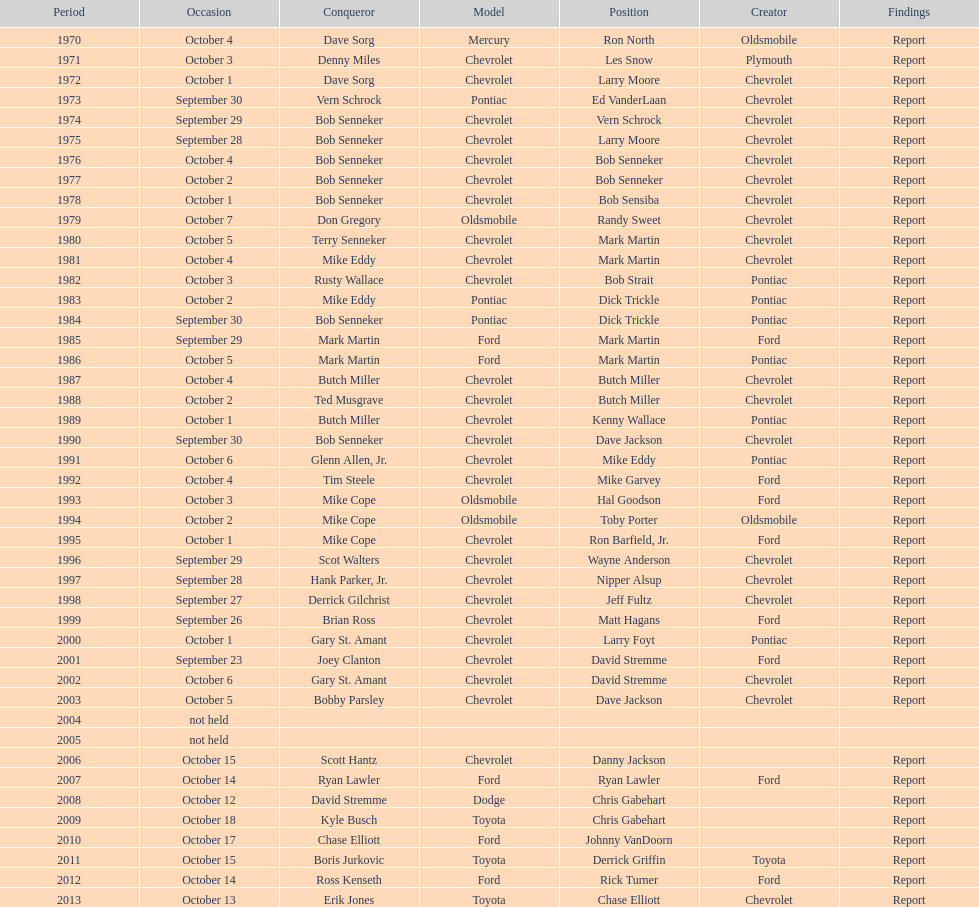Which make was used the least? Mercury. 